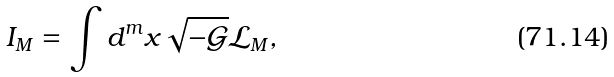Convert formula to latex. <formula><loc_0><loc_0><loc_500><loc_500>I _ { M } = \int d ^ { m } x \sqrt { - \mathcal { G } } \mathcal { L } _ { M } ,</formula> 